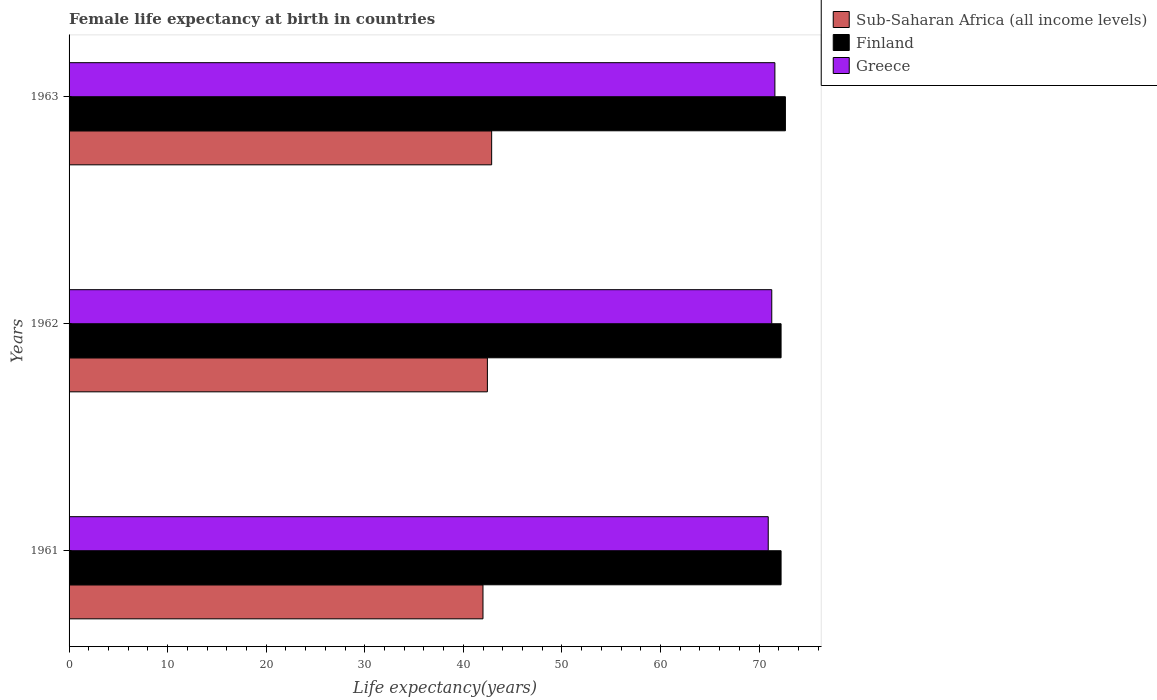How many different coloured bars are there?
Keep it short and to the point. 3. How many groups of bars are there?
Offer a very short reply. 3. Are the number of bars per tick equal to the number of legend labels?
Offer a very short reply. Yes. How many bars are there on the 3rd tick from the top?
Give a very brief answer. 3. What is the label of the 3rd group of bars from the top?
Provide a short and direct response. 1961. What is the female life expectancy at birth in Sub-Saharan Africa (all income levels) in 1963?
Offer a very short reply. 42.88. Across all years, what is the maximum female life expectancy at birth in Greece?
Offer a very short reply. 71.61. Across all years, what is the minimum female life expectancy at birth in Sub-Saharan Africa (all income levels)?
Offer a very short reply. 42. In which year was the female life expectancy at birth in Finland minimum?
Keep it short and to the point. 1961. What is the total female life expectancy at birth in Finland in the graph?
Ensure brevity in your answer.  217.16. What is the difference between the female life expectancy at birth in Sub-Saharan Africa (all income levels) in 1961 and that in 1963?
Ensure brevity in your answer.  -0.88. What is the difference between the female life expectancy at birth in Sub-Saharan Africa (all income levels) in 1961 and the female life expectancy at birth in Finland in 1963?
Give a very brief answer. -30.68. What is the average female life expectancy at birth in Finland per year?
Give a very brief answer. 72.39. In the year 1961, what is the difference between the female life expectancy at birth in Greece and female life expectancy at birth in Finland?
Your answer should be very brief. -1.3. In how many years, is the female life expectancy at birth in Greece greater than 62 years?
Give a very brief answer. 3. What is the ratio of the female life expectancy at birth in Sub-Saharan Africa (all income levels) in 1961 to that in 1962?
Keep it short and to the point. 0.99. Is the female life expectancy at birth in Sub-Saharan Africa (all income levels) in 1961 less than that in 1963?
Provide a succinct answer. Yes. What is the difference between the highest and the second highest female life expectancy at birth in Finland?
Keep it short and to the point. 0.44. What is the difference between the highest and the lowest female life expectancy at birth in Finland?
Provide a succinct answer. 0.44. How many bars are there?
Your response must be concise. 9. Are all the bars in the graph horizontal?
Ensure brevity in your answer.  Yes. How many years are there in the graph?
Your answer should be compact. 3. Are the values on the major ticks of X-axis written in scientific E-notation?
Ensure brevity in your answer.  No. Does the graph contain any zero values?
Your answer should be very brief. No. Does the graph contain grids?
Ensure brevity in your answer.  No. Where does the legend appear in the graph?
Your answer should be very brief. Top right. How many legend labels are there?
Your response must be concise. 3. What is the title of the graph?
Provide a short and direct response. Female life expectancy at birth in countries. What is the label or title of the X-axis?
Offer a very short reply. Life expectancy(years). What is the label or title of the Y-axis?
Your answer should be very brief. Years. What is the Life expectancy(years) in Sub-Saharan Africa (all income levels) in 1961?
Your answer should be very brief. 42. What is the Life expectancy(years) in Finland in 1961?
Keep it short and to the point. 72.24. What is the Life expectancy(years) in Greece in 1961?
Your answer should be very brief. 70.94. What is the Life expectancy(years) in Sub-Saharan Africa (all income levels) in 1962?
Offer a terse response. 42.44. What is the Life expectancy(years) in Finland in 1962?
Offer a terse response. 72.24. What is the Life expectancy(years) in Greece in 1962?
Keep it short and to the point. 71.3. What is the Life expectancy(years) of Sub-Saharan Africa (all income levels) in 1963?
Your answer should be compact. 42.88. What is the Life expectancy(years) in Finland in 1963?
Offer a very short reply. 72.68. What is the Life expectancy(years) of Greece in 1963?
Your response must be concise. 71.61. Across all years, what is the maximum Life expectancy(years) in Sub-Saharan Africa (all income levels)?
Offer a very short reply. 42.88. Across all years, what is the maximum Life expectancy(years) of Finland?
Give a very brief answer. 72.68. Across all years, what is the maximum Life expectancy(years) in Greece?
Your answer should be compact. 71.61. Across all years, what is the minimum Life expectancy(years) of Sub-Saharan Africa (all income levels)?
Ensure brevity in your answer.  42. Across all years, what is the minimum Life expectancy(years) of Finland?
Offer a terse response. 72.24. Across all years, what is the minimum Life expectancy(years) of Greece?
Provide a succinct answer. 70.94. What is the total Life expectancy(years) of Sub-Saharan Africa (all income levels) in the graph?
Offer a very short reply. 127.32. What is the total Life expectancy(years) of Finland in the graph?
Give a very brief answer. 217.16. What is the total Life expectancy(years) in Greece in the graph?
Offer a terse response. 213.85. What is the difference between the Life expectancy(years) of Sub-Saharan Africa (all income levels) in 1961 and that in 1962?
Make the answer very short. -0.45. What is the difference between the Life expectancy(years) of Finland in 1961 and that in 1962?
Offer a terse response. 0. What is the difference between the Life expectancy(years) in Greece in 1961 and that in 1962?
Make the answer very short. -0.36. What is the difference between the Life expectancy(years) in Sub-Saharan Africa (all income levels) in 1961 and that in 1963?
Your response must be concise. -0.88. What is the difference between the Life expectancy(years) in Finland in 1961 and that in 1963?
Provide a succinct answer. -0.44. What is the difference between the Life expectancy(years) in Greece in 1961 and that in 1963?
Your answer should be very brief. -0.68. What is the difference between the Life expectancy(years) of Sub-Saharan Africa (all income levels) in 1962 and that in 1963?
Your answer should be very brief. -0.43. What is the difference between the Life expectancy(years) in Finland in 1962 and that in 1963?
Keep it short and to the point. -0.44. What is the difference between the Life expectancy(years) in Greece in 1962 and that in 1963?
Your response must be concise. -0.32. What is the difference between the Life expectancy(years) in Sub-Saharan Africa (all income levels) in 1961 and the Life expectancy(years) in Finland in 1962?
Ensure brevity in your answer.  -30.24. What is the difference between the Life expectancy(years) of Sub-Saharan Africa (all income levels) in 1961 and the Life expectancy(years) of Greece in 1962?
Your response must be concise. -29.3. What is the difference between the Life expectancy(years) of Finland in 1961 and the Life expectancy(years) of Greece in 1962?
Give a very brief answer. 0.94. What is the difference between the Life expectancy(years) of Sub-Saharan Africa (all income levels) in 1961 and the Life expectancy(years) of Finland in 1963?
Offer a terse response. -30.68. What is the difference between the Life expectancy(years) of Sub-Saharan Africa (all income levels) in 1961 and the Life expectancy(years) of Greece in 1963?
Offer a terse response. -29.62. What is the difference between the Life expectancy(years) of Finland in 1961 and the Life expectancy(years) of Greece in 1963?
Keep it short and to the point. 0.63. What is the difference between the Life expectancy(years) in Sub-Saharan Africa (all income levels) in 1962 and the Life expectancy(years) in Finland in 1963?
Make the answer very short. -30.24. What is the difference between the Life expectancy(years) of Sub-Saharan Africa (all income levels) in 1962 and the Life expectancy(years) of Greece in 1963?
Your response must be concise. -29.17. What is the difference between the Life expectancy(years) in Finland in 1962 and the Life expectancy(years) in Greece in 1963?
Give a very brief answer. 0.63. What is the average Life expectancy(years) in Sub-Saharan Africa (all income levels) per year?
Offer a terse response. 42.44. What is the average Life expectancy(years) in Finland per year?
Offer a terse response. 72.39. What is the average Life expectancy(years) of Greece per year?
Ensure brevity in your answer.  71.28. In the year 1961, what is the difference between the Life expectancy(years) in Sub-Saharan Africa (all income levels) and Life expectancy(years) in Finland?
Your answer should be very brief. -30.24. In the year 1961, what is the difference between the Life expectancy(years) of Sub-Saharan Africa (all income levels) and Life expectancy(years) of Greece?
Provide a short and direct response. -28.94. In the year 1961, what is the difference between the Life expectancy(years) of Finland and Life expectancy(years) of Greece?
Your answer should be very brief. 1.3. In the year 1962, what is the difference between the Life expectancy(years) of Sub-Saharan Africa (all income levels) and Life expectancy(years) of Finland?
Give a very brief answer. -29.8. In the year 1962, what is the difference between the Life expectancy(years) of Sub-Saharan Africa (all income levels) and Life expectancy(years) of Greece?
Make the answer very short. -28.85. In the year 1962, what is the difference between the Life expectancy(years) in Finland and Life expectancy(years) in Greece?
Give a very brief answer. 0.94. In the year 1963, what is the difference between the Life expectancy(years) in Sub-Saharan Africa (all income levels) and Life expectancy(years) in Finland?
Make the answer very short. -29.8. In the year 1963, what is the difference between the Life expectancy(years) of Sub-Saharan Africa (all income levels) and Life expectancy(years) of Greece?
Give a very brief answer. -28.74. In the year 1963, what is the difference between the Life expectancy(years) in Finland and Life expectancy(years) in Greece?
Offer a terse response. 1.07. What is the ratio of the Life expectancy(years) in Sub-Saharan Africa (all income levels) in 1961 to that in 1963?
Keep it short and to the point. 0.98. What is the ratio of the Life expectancy(years) of Finland in 1961 to that in 1963?
Provide a short and direct response. 0.99. What is the ratio of the Life expectancy(years) of Greece in 1961 to that in 1963?
Ensure brevity in your answer.  0.99. What is the ratio of the Life expectancy(years) of Finland in 1962 to that in 1963?
Make the answer very short. 0.99. What is the difference between the highest and the second highest Life expectancy(years) in Sub-Saharan Africa (all income levels)?
Offer a very short reply. 0.43. What is the difference between the highest and the second highest Life expectancy(years) of Finland?
Provide a succinct answer. 0.44. What is the difference between the highest and the second highest Life expectancy(years) in Greece?
Your answer should be compact. 0.32. What is the difference between the highest and the lowest Life expectancy(years) in Finland?
Your response must be concise. 0.44. What is the difference between the highest and the lowest Life expectancy(years) of Greece?
Offer a terse response. 0.68. 